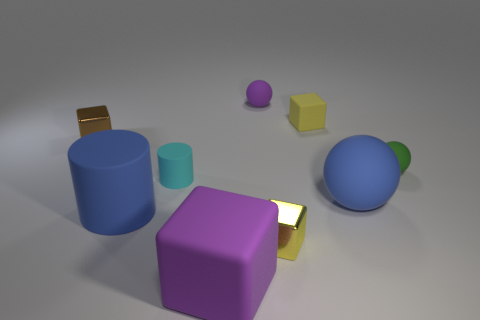What emotions or concepts might these objects represent if this were an abstract art piece? Interpreted as an abstract art piece, these objects could represent a variety of emotions or concepts. The cool blue and cyan cylinders might evoke feelings of calmness or serenity, while the vibrant yellow and purple could suggest playfulness or creativity. The stoic golden cube could symbolize value or stability. Overall, the arrangement and choice of colors might stimulate a contemplation on diversity and harmony, suggesting a world where different elements coexist peacefully. 